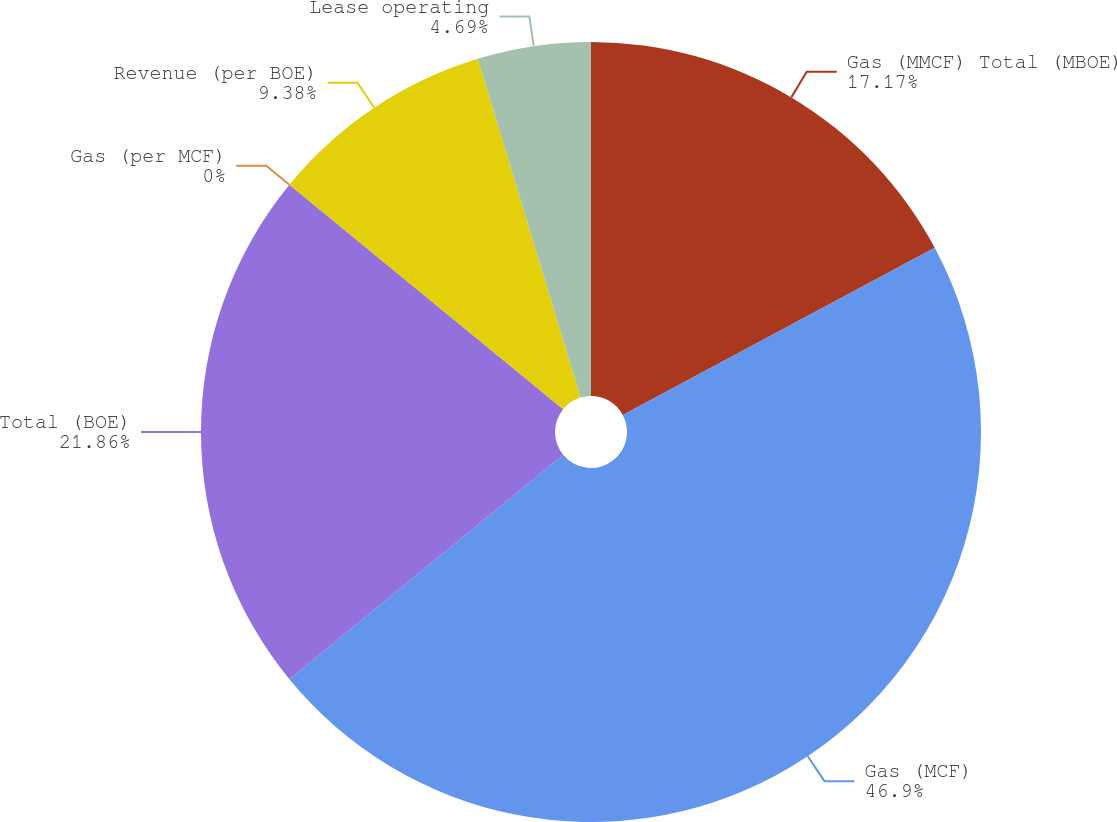Convert chart. <chart><loc_0><loc_0><loc_500><loc_500><pie_chart><fcel>Gas (MMCF) Total (MBOE)<fcel>Gas (MCF)<fcel>Total (BOE)<fcel>Gas (per MCF)<fcel>Revenue (per BOE)<fcel>Lease operating<nl><fcel>17.17%<fcel>46.9%<fcel>21.86%<fcel>0.0%<fcel>9.38%<fcel>4.69%<nl></chart> 